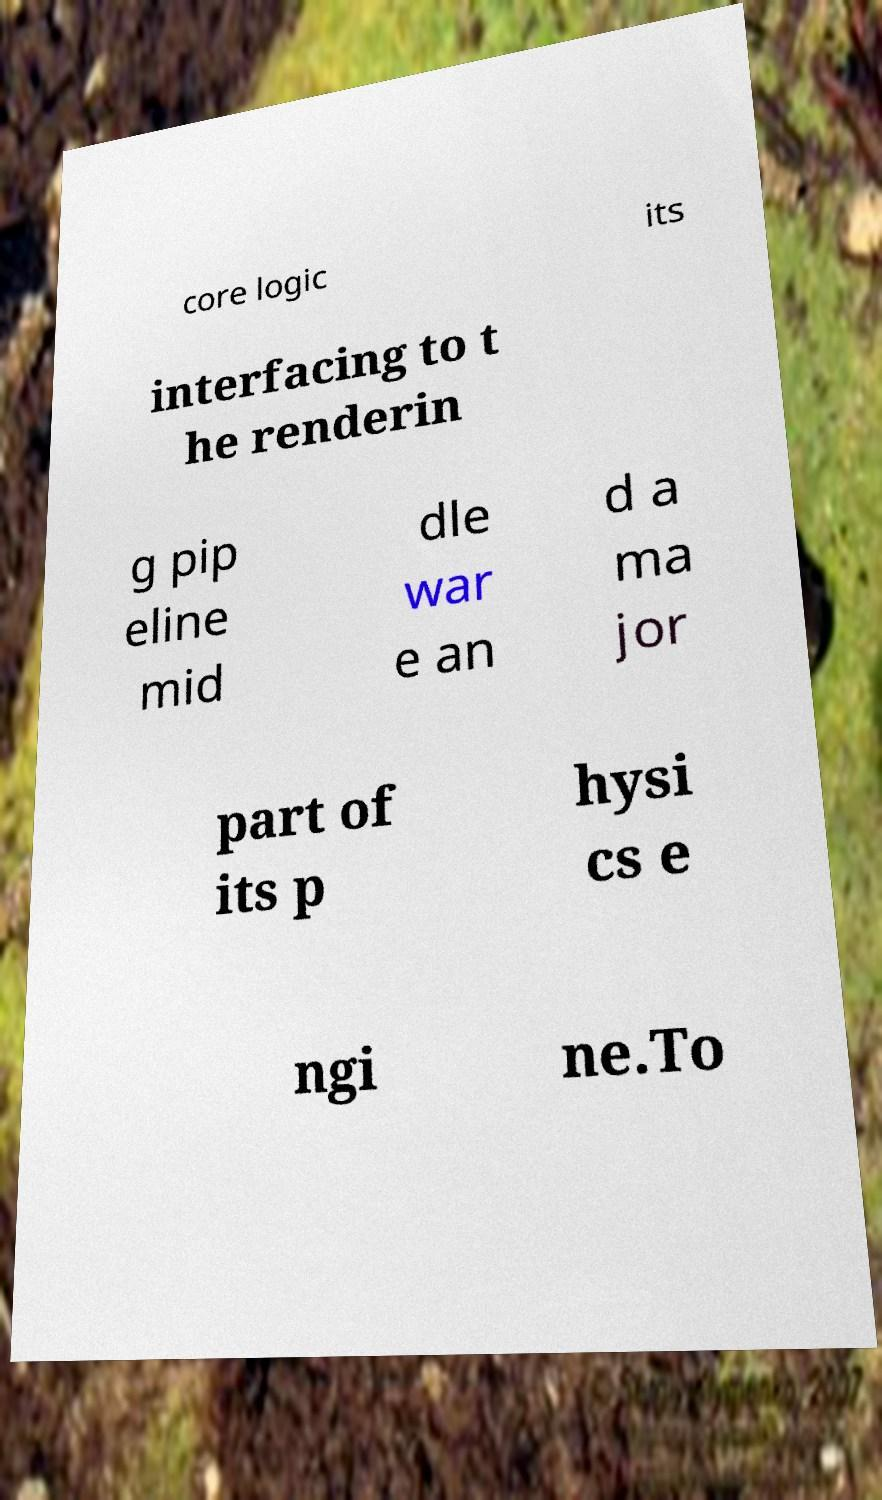I need the written content from this picture converted into text. Can you do that? core logic its interfacing to t he renderin g pip eline mid dle war e an d a ma jor part of its p hysi cs e ngi ne.To 